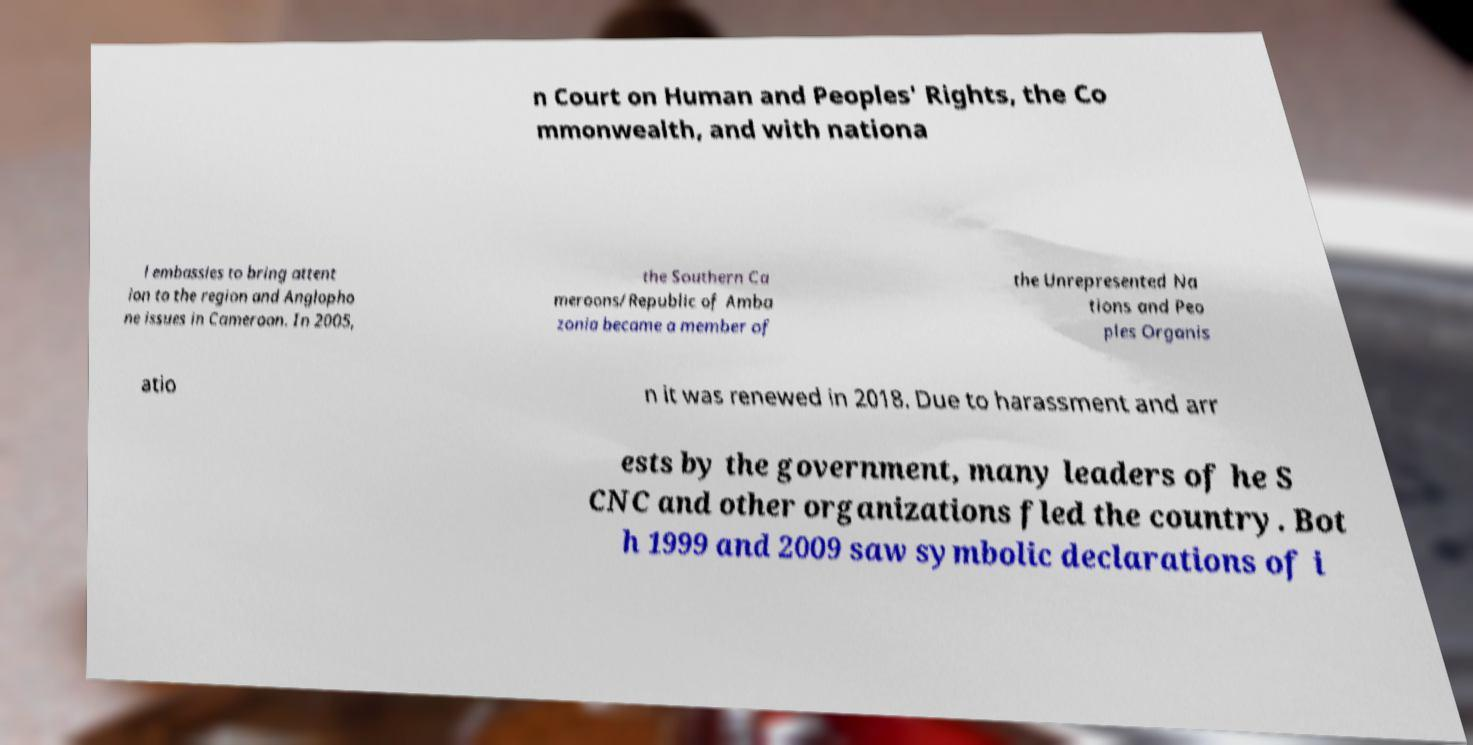For documentation purposes, I need the text within this image transcribed. Could you provide that? n Court on Human and Peoples' Rights, the Co mmonwealth, and with nationa l embassies to bring attent ion to the region and Anglopho ne issues in Cameroon. In 2005, the Southern Ca meroons/Republic of Amba zonia became a member of the Unrepresented Na tions and Peo ples Organis atio n it was renewed in 2018. Due to harassment and arr ests by the government, many leaders of he S CNC and other organizations fled the country. Bot h 1999 and 2009 saw symbolic declarations of i 